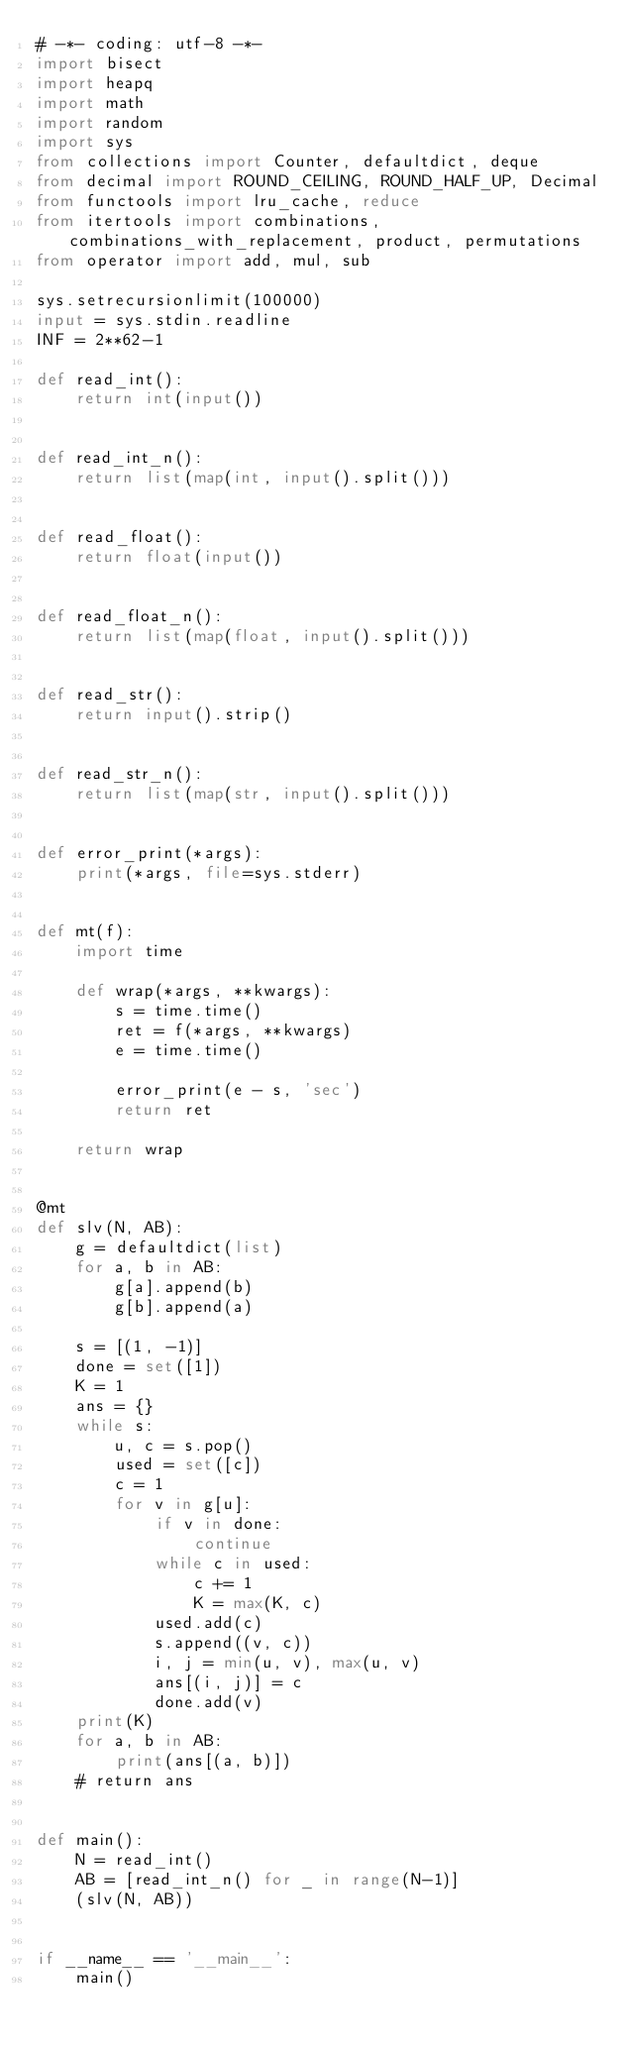<code> <loc_0><loc_0><loc_500><loc_500><_Python_># -*- coding: utf-8 -*-
import bisect
import heapq
import math
import random
import sys
from collections import Counter, defaultdict, deque
from decimal import ROUND_CEILING, ROUND_HALF_UP, Decimal
from functools import lru_cache, reduce
from itertools import combinations, combinations_with_replacement, product, permutations
from operator import add, mul, sub

sys.setrecursionlimit(100000)
input = sys.stdin.readline
INF = 2**62-1

def read_int():
    return int(input())


def read_int_n():
    return list(map(int, input().split()))


def read_float():
    return float(input())


def read_float_n():
    return list(map(float, input().split()))


def read_str():
    return input().strip()


def read_str_n():
    return list(map(str, input().split()))


def error_print(*args):
    print(*args, file=sys.stderr)


def mt(f):
    import time

    def wrap(*args, **kwargs):
        s = time.time()
        ret = f(*args, **kwargs)
        e = time.time()

        error_print(e - s, 'sec')
        return ret

    return wrap


@mt
def slv(N, AB):
    g = defaultdict(list)
    for a, b in AB:
        g[a].append(b)
        g[b].append(a)
        
    s = [(1, -1)]
    done = set([1])
    K = 1
    ans = {}
    while s:
        u, c = s.pop()
        used = set([c])
        c = 1
        for v in g[u]:
            if v in done:
                continue
            while c in used:
                c += 1 
                K = max(K, c)
            used.add(c)
            s.append((v, c))
            i, j = min(u, v), max(u, v)
            ans[(i, j)] = c
            done.add(v)
    print(K)
    for a, b in AB:
        print(ans[(a, b)])
    # return ans


def main():
    N = read_int()
    AB = [read_int_n() for _ in range(N-1)]
    (slv(N, AB))


if __name__ == '__main__':
    main()
</code> 